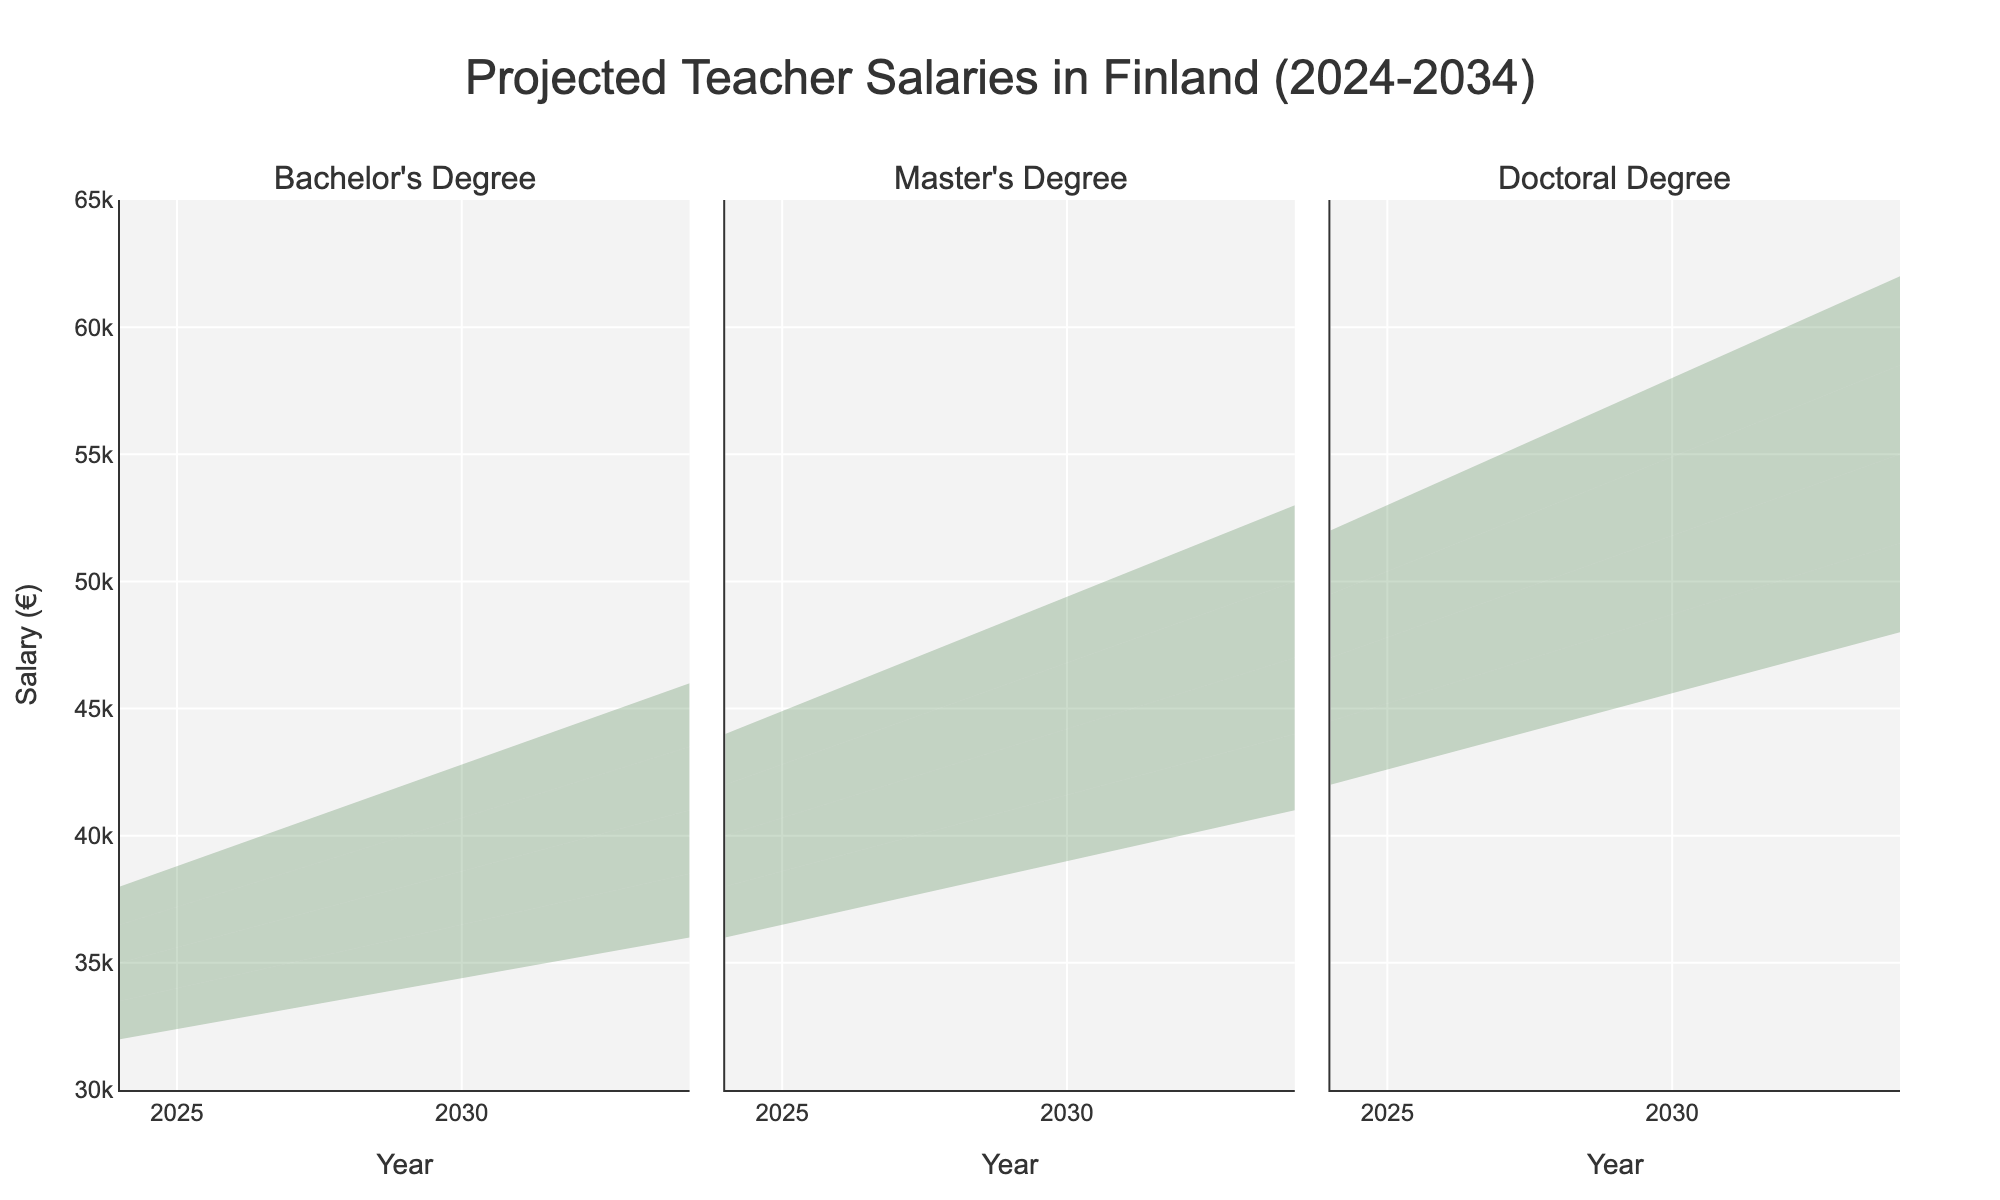What is the highest projected salary for a Master's Degree holder in 2029? Look at the subplot for the Master's Degree on the chart and find the projections for 2029. The highest estimate is shown as the topmost line.
Answer: €48,500 What is the difference between the mid estimates for Bachelor's and Doctoral Degrees in 2034? Locate the mid estimates on the Bachelor's and Doctoral Degree plots for 2034. For Bachelor's, it's €41,000, and for Doctoral, it's €55,000. Subtract the Bachelor's mid estimate from the Doctoral mid estimate (€55,000 - €41,000).
Answer: €14,000 Which education level shows the highest increase in mid estimates from 2024 to 2034? Identify the mid estimates for each education level in 2024 and 2034. Calculate the difference for each level: Bachelor's goes from €35,000 to €41,000, Master's from €40,000 to €47,000, and Doctoral from €47,000 to €55,000. The Doctoral Degree shows the highest increase (€55,000 - €47,000).
Answer: Doctoral Degree What is the range of salary projections for a Bachelor's Degree holder in 2029? Find the highest and lowest estimates on the Bachelor’s Degree plot for 2029. The highest estimate is €42,000 and the lowest estimate is €34,000. Calculate the range (€42,000 - €34,000).
Answer: €8,000 Between 2024 and 2029, do all education levels exhibit an increase in their mid estimates? Check the mid estimates for 2024 and 2029 for each education level: Bachelor's increases from €35,000 to €38,000, Master's from €40,000 to €43,500, and Doctoral from €47,000 to €51,000. All levels show an increase.
Answer: Yes By how much does the high estimate for a Bachelor's Degree increase between 2024 and 2034? Locate the high estimates for a Bachelor's Degree in the plots for 2024 and 2034: €38,000 in 2024, and €46,000 in 2034. Calculate the difference (€46,000 - €38,000).
Answer: €8,000 What is the projected salary range for a Doctoral Degree holder in 2034? Identify the highest and lowest estimates on the Doctoral Degree plot for 2034. The highest estimate is €62,000 and the lowest is €48,000.
Answer: €48,000 - €62,000 